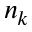<formula> <loc_0><loc_0><loc_500><loc_500>n _ { k }</formula> 